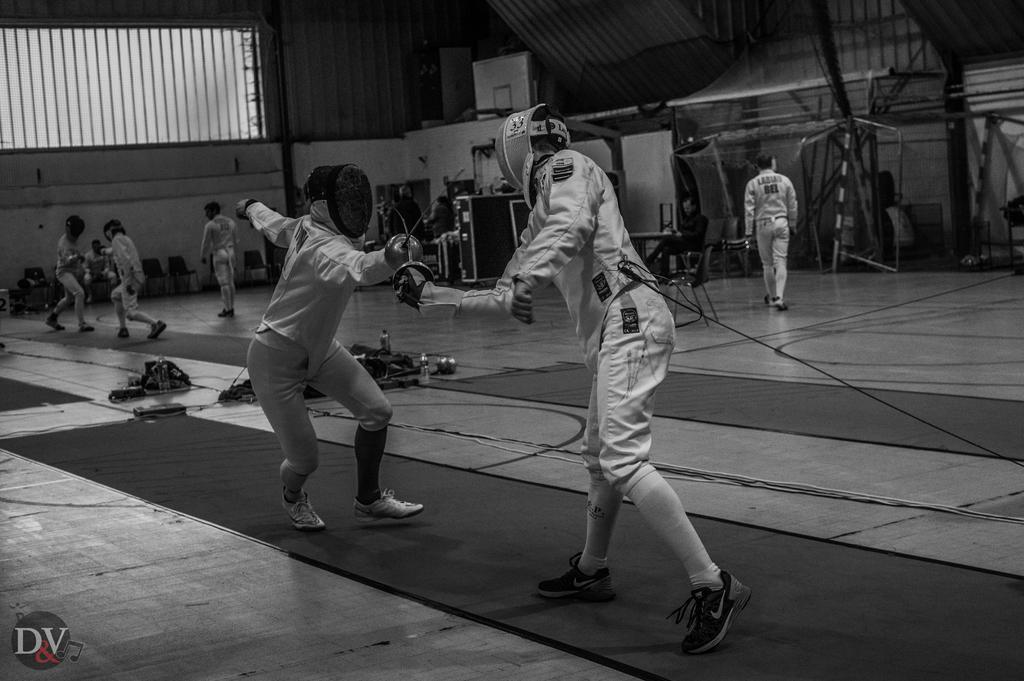Please provide a concise description of this image. In this picture we can see a few people holding swords in their hands. We can see some objects on the floor. There are few chairs on the left side. We can see a man sitting on a chair. There is a steel roofing sheet on top. 